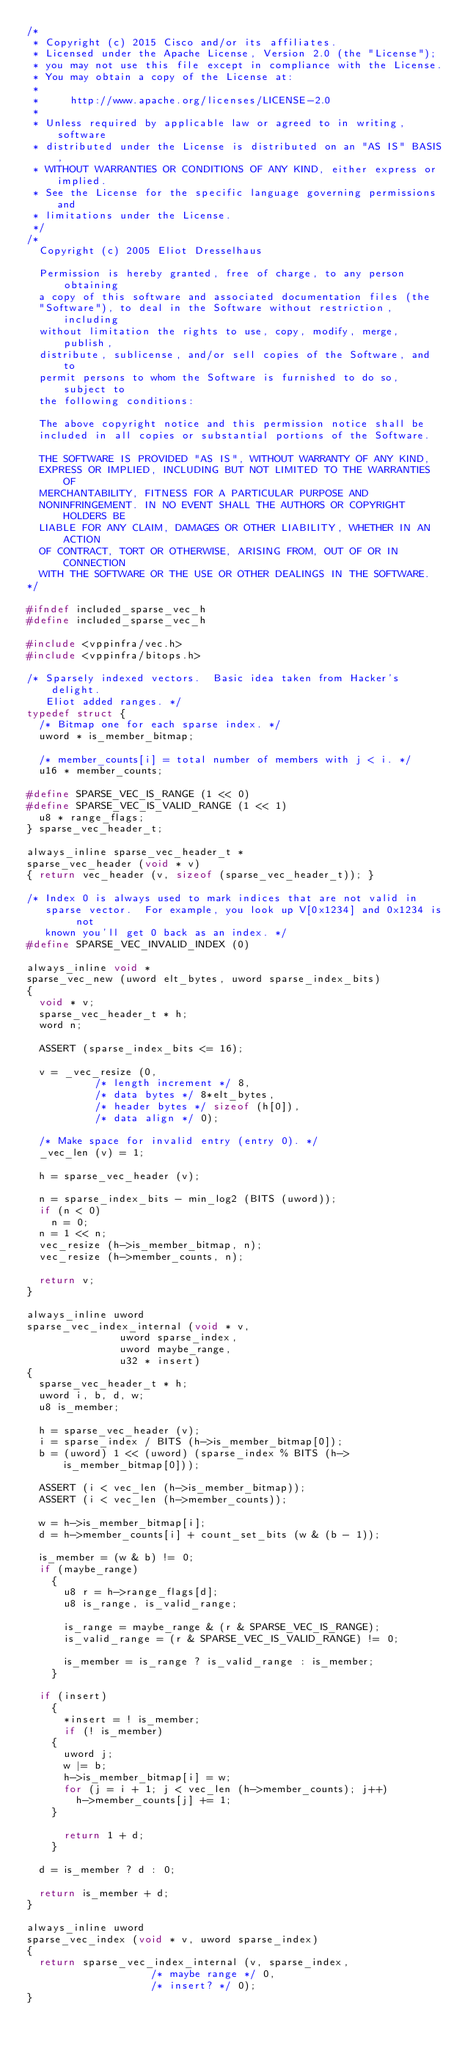<code> <loc_0><loc_0><loc_500><loc_500><_C_>/*
 * Copyright (c) 2015 Cisco and/or its affiliates.
 * Licensed under the Apache License, Version 2.0 (the "License");
 * you may not use this file except in compliance with the License.
 * You may obtain a copy of the License at:
 *
 *     http://www.apache.org/licenses/LICENSE-2.0
 *
 * Unless required by applicable law or agreed to in writing, software
 * distributed under the License is distributed on an "AS IS" BASIS,
 * WITHOUT WARRANTIES OR CONDITIONS OF ANY KIND, either express or implied.
 * See the License for the specific language governing permissions and
 * limitations under the License.
 */
/*
  Copyright (c) 2005 Eliot Dresselhaus

  Permission is hereby granted, free of charge, to any person obtaining
  a copy of this software and associated documentation files (the
  "Software"), to deal in the Software without restriction, including
  without limitation the rights to use, copy, modify, merge, publish,
  distribute, sublicense, and/or sell copies of the Software, and to
  permit persons to whom the Software is furnished to do so, subject to
  the following conditions:

  The above copyright notice and this permission notice shall be
  included in all copies or substantial portions of the Software.

  THE SOFTWARE IS PROVIDED "AS IS", WITHOUT WARRANTY OF ANY KIND,
  EXPRESS OR IMPLIED, INCLUDING BUT NOT LIMITED TO THE WARRANTIES OF
  MERCHANTABILITY, FITNESS FOR A PARTICULAR PURPOSE AND
  NONINFRINGEMENT. IN NO EVENT SHALL THE AUTHORS OR COPYRIGHT HOLDERS BE
  LIABLE FOR ANY CLAIM, DAMAGES OR OTHER LIABILITY, WHETHER IN AN ACTION
  OF CONTRACT, TORT OR OTHERWISE, ARISING FROM, OUT OF OR IN CONNECTION
  WITH THE SOFTWARE OR THE USE OR OTHER DEALINGS IN THE SOFTWARE.
*/

#ifndef included_sparse_vec_h
#define included_sparse_vec_h

#include <vppinfra/vec.h>
#include <vppinfra/bitops.h>

/* Sparsely indexed vectors.  Basic idea taken from Hacker's delight.
   Eliot added ranges. */
typedef struct {
  /* Bitmap one for each sparse index. */
  uword * is_member_bitmap;

  /* member_counts[i] = total number of members with j < i. */
  u16 * member_counts;

#define SPARSE_VEC_IS_RANGE (1 << 0)
#define SPARSE_VEC_IS_VALID_RANGE (1 << 1)
  u8 * range_flags;
} sparse_vec_header_t;

always_inline sparse_vec_header_t *
sparse_vec_header (void * v)
{ return vec_header (v, sizeof (sparse_vec_header_t)); }

/* Index 0 is always used to mark indices that are not valid in
   sparse vector.  For example, you look up V[0x1234] and 0x1234 is not
   known you'll get 0 back as an index. */
#define SPARSE_VEC_INVALID_INDEX (0)

always_inline void *
sparse_vec_new (uword elt_bytes, uword sparse_index_bits)
{
  void * v;
  sparse_vec_header_t * h;
  word n;

  ASSERT (sparse_index_bits <= 16);

  v = _vec_resize (0,
		   /* length increment */ 8,
		   /* data bytes */ 8*elt_bytes,
		   /* header bytes */ sizeof (h[0]),
		   /* data align */ 0);

  /* Make space for invalid entry (entry 0). */
  _vec_len (v) = 1;

  h = sparse_vec_header (v);

  n = sparse_index_bits - min_log2 (BITS (uword));
  if (n < 0)
    n = 0;
  n = 1 << n;
  vec_resize (h->is_member_bitmap, n);
  vec_resize (h->member_counts, n);

  return v;
}

always_inline uword
sparse_vec_index_internal (void * v,
			   uword sparse_index,
			   uword maybe_range,
			   u32 * insert)
{
  sparse_vec_header_t * h;
  uword i, b, d, w;
  u8 is_member;

  h = sparse_vec_header (v);
  i = sparse_index / BITS (h->is_member_bitmap[0]);
  b = (uword) 1 << (uword) (sparse_index % BITS (h->is_member_bitmap[0]));

  ASSERT (i < vec_len (h->is_member_bitmap));
  ASSERT (i < vec_len (h->member_counts));

  w = h->is_member_bitmap[i];
  d = h->member_counts[i] + count_set_bits (w & (b - 1));

  is_member = (w & b) != 0;
  if (maybe_range)
    {
      u8 r = h->range_flags[d];
      u8 is_range, is_valid_range;

      is_range = maybe_range & (r & SPARSE_VEC_IS_RANGE);
      is_valid_range = (r & SPARSE_VEC_IS_VALID_RANGE) != 0;

      is_member = is_range ? is_valid_range : is_member;
    }

  if (insert)
    {
      *insert = ! is_member;
      if (! is_member)
	{
	  uword j;
	  w |= b;
	  h->is_member_bitmap[i] = w;
	  for (j = i + 1; j < vec_len (h->member_counts); j++)
	    h->member_counts[j] += 1;
	}

      return 1 + d;
    }

  d = is_member ? d : 0;

  return is_member + d;
}

always_inline uword
sparse_vec_index (void * v, uword sparse_index)
{
  return sparse_vec_index_internal (v, sparse_index,
				    /* maybe range */ 0,
				    /* insert? */ 0);
}
				    </code> 